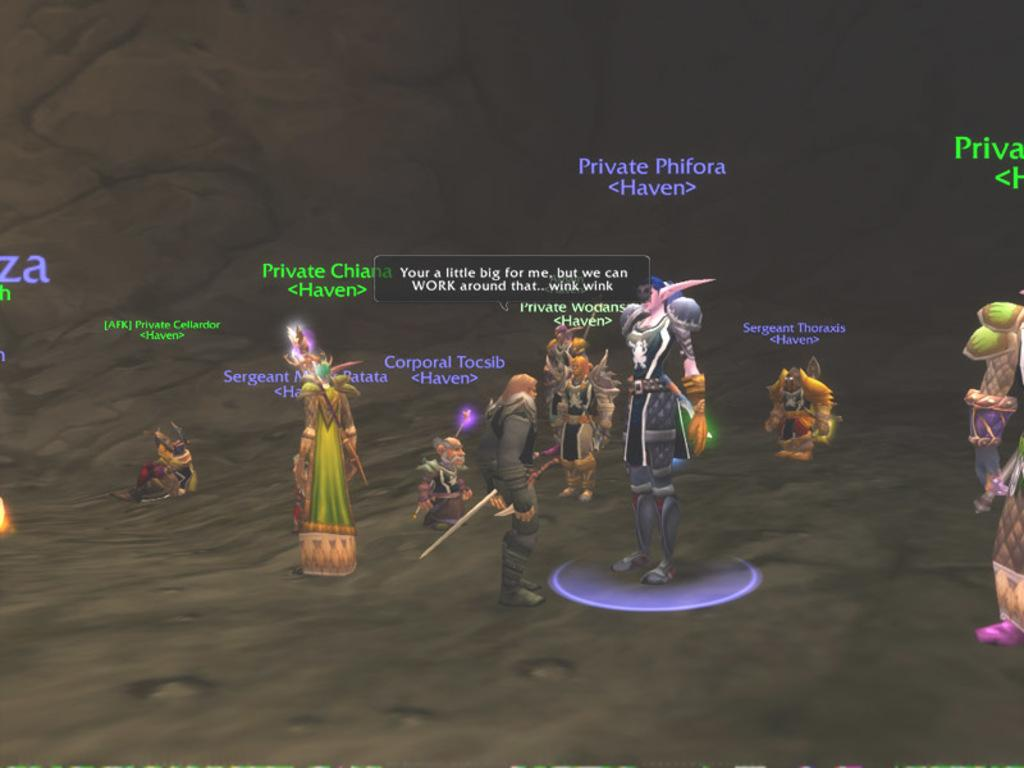What type of picture is in the image? The image contains an animated picture. Can you describe the people in the image? There are people standing in the image. What are the people holding in the image? The people are holding objects. Is there any text present in the image? Yes, there is text written on the image. How many teeth can be seen in the image? There are no teeth visible in the image. What type of boys are present in the image? There is no mention of boys in the image; the facts only mention people in general. 